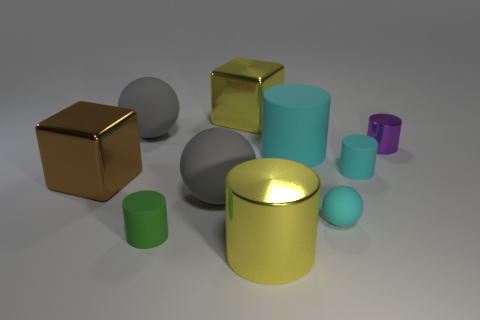Which object appears to be closest to the viewer? The closest object to the viewer seems to be the green cylinder on the left, given its size and position in the foreground of the image. Could you estimate its size relative to the other objects? While it's difficult to estimate exact sizes without a reference, the green cylinder appears to be one of the smaller objects in comparison to others, like the larger teal and purple cylinders. 